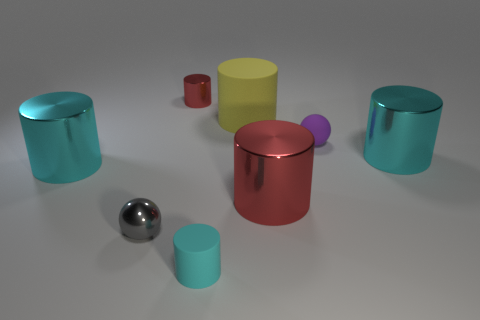There is a purple thing behind the tiny cylinder that is in front of the red cylinder on the right side of the tiny red metal thing; what size is it?
Ensure brevity in your answer.  Small. Is there a large cyan metallic cylinder on the right side of the big cyan cylinder that is to the left of the cyan shiny object that is to the right of the purple matte sphere?
Keep it short and to the point. Yes. Is the number of small purple rubber objects greater than the number of red metallic cylinders?
Your answer should be very brief. No. There is a shiny cylinder left of the small shiny cylinder; what color is it?
Keep it short and to the point. Cyan. Are there more large shiny objects on the left side of the gray object than blue cylinders?
Provide a succinct answer. Yes. Are the purple ball and the big red cylinder made of the same material?
Offer a terse response. No. How many other things are the same shape as the tiny purple rubber thing?
Your response must be concise. 1. The ball that is on the right side of the cyan object in front of the red thing in front of the rubber ball is what color?
Your response must be concise. Purple. There is a small thing that is to the right of the tiny cyan cylinder; does it have the same shape as the small gray shiny object?
Offer a very short reply. Yes. What number of matte things are there?
Give a very brief answer. 3. 